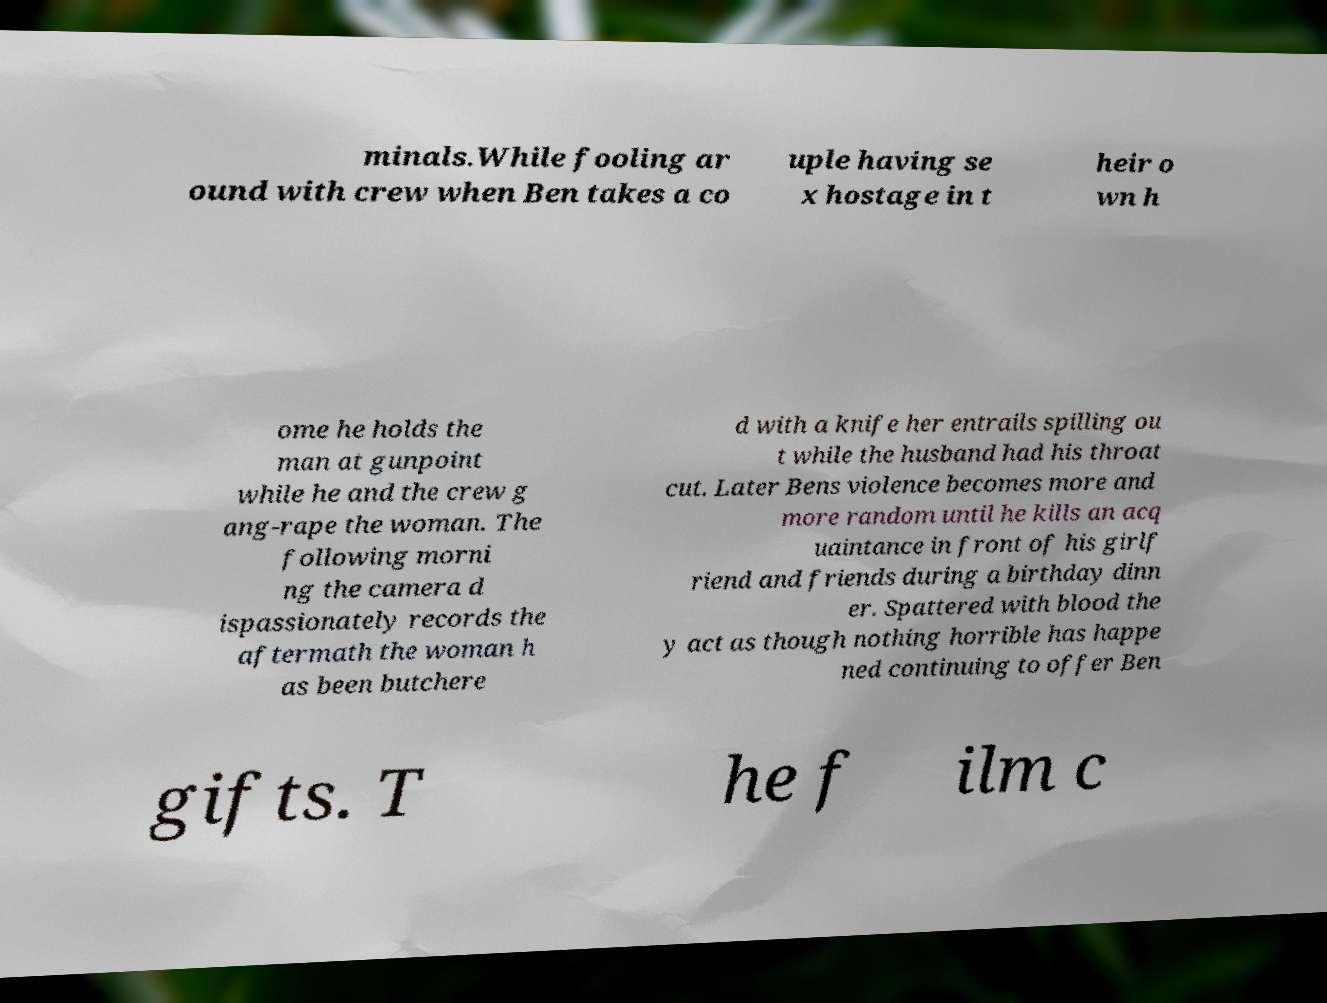Could you assist in decoding the text presented in this image and type it out clearly? minals.While fooling ar ound with crew when Ben takes a co uple having se x hostage in t heir o wn h ome he holds the man at gunpoint while he and the crew g ang-rape the woman. The following morni ng the camera d ispassionately records the aftermath the woman h as been butchere d with a knife her entrails spilling ou t while the husband had his throat cut. Later Bens violence becomes more and more random until he kills an acq uaintance in front of his girlf riend and friends during a birthday dinn er. Spattered with blood the y act as though nothing horrible has happe ned continuing to offer Ben gifts. T he f ilm c 